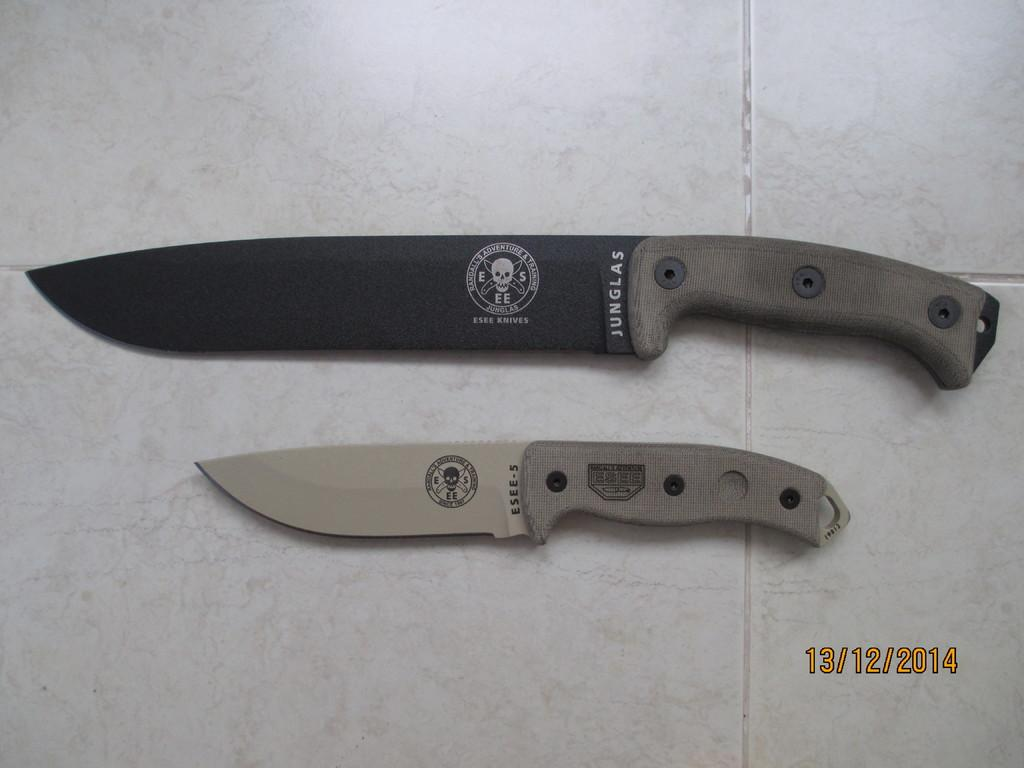<image>
Share a concise interpretation of the image provided. A black knife with a skull design and the words Junglas written on it with a silver knife below it with the Essee-5 written on it. 